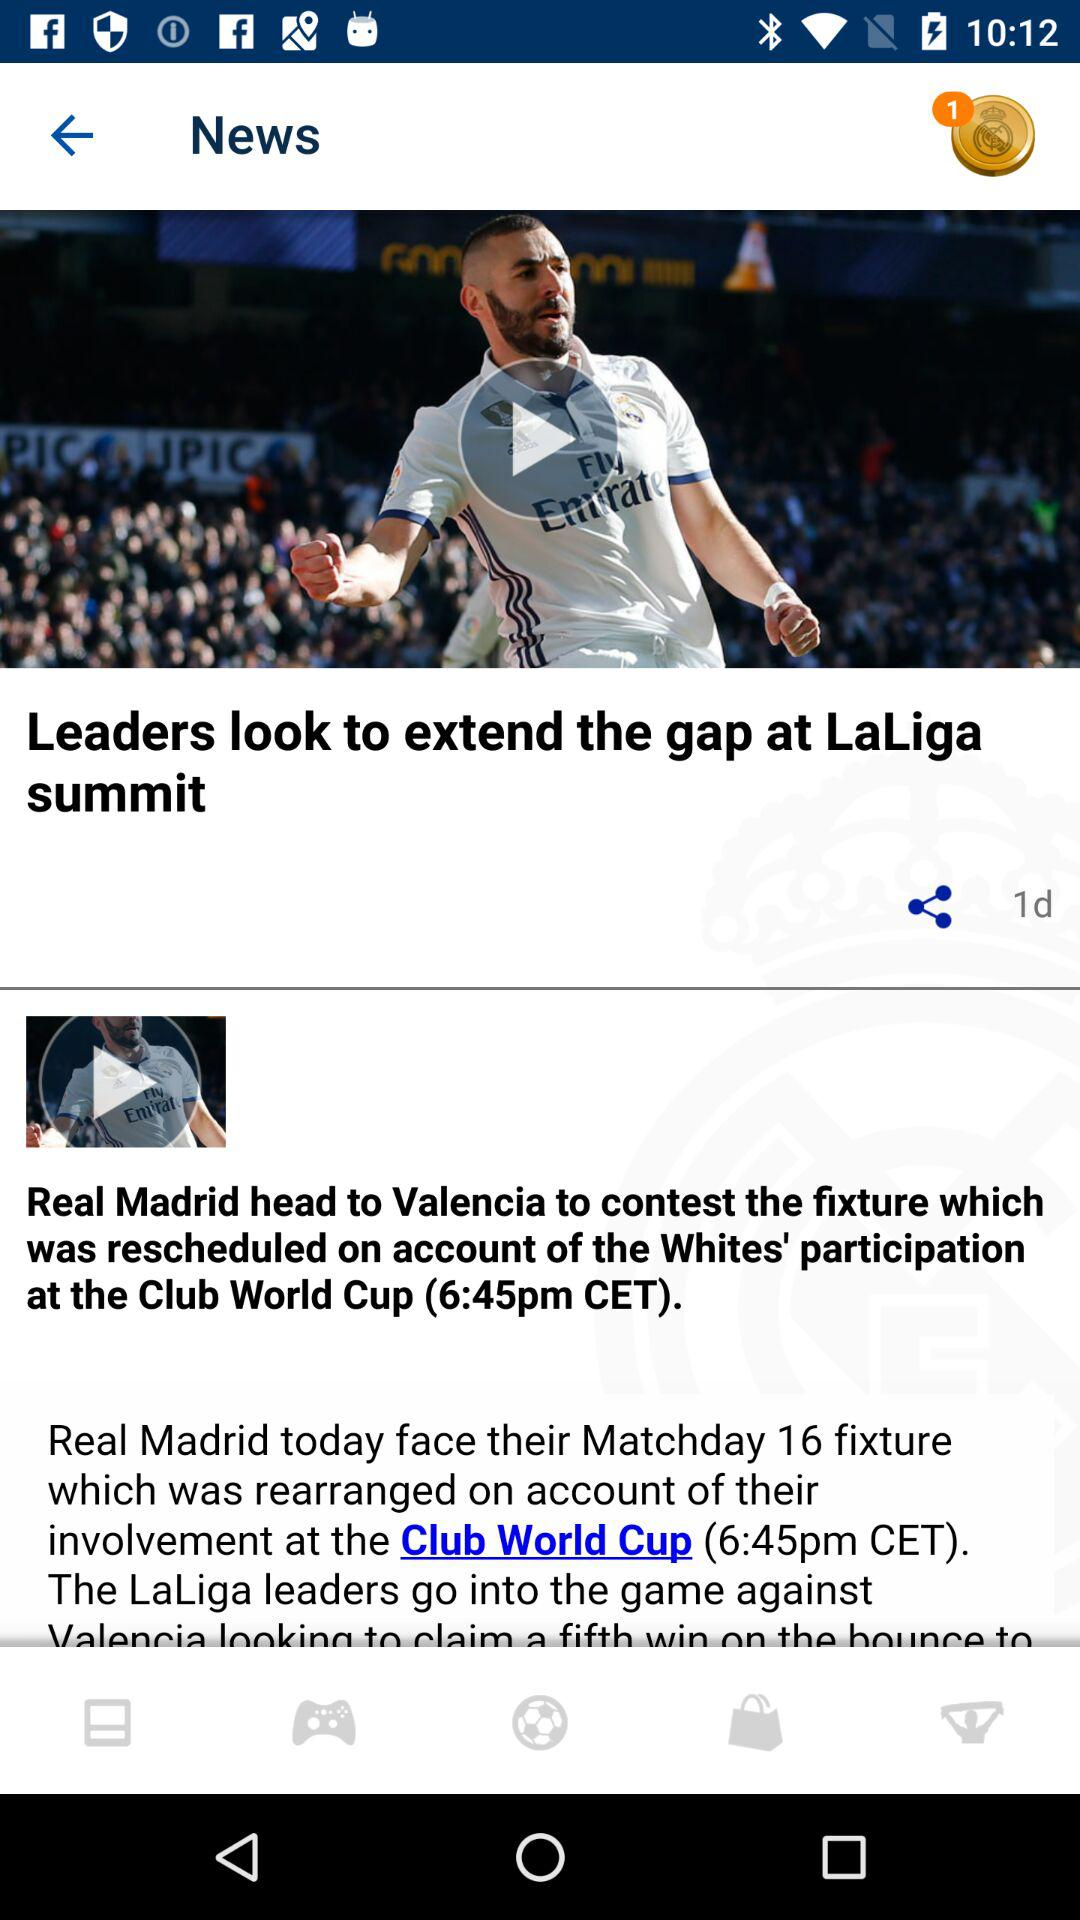What is the title of the article? The title of the article is "Leaders look to extend the gap at LaLiga summit". 